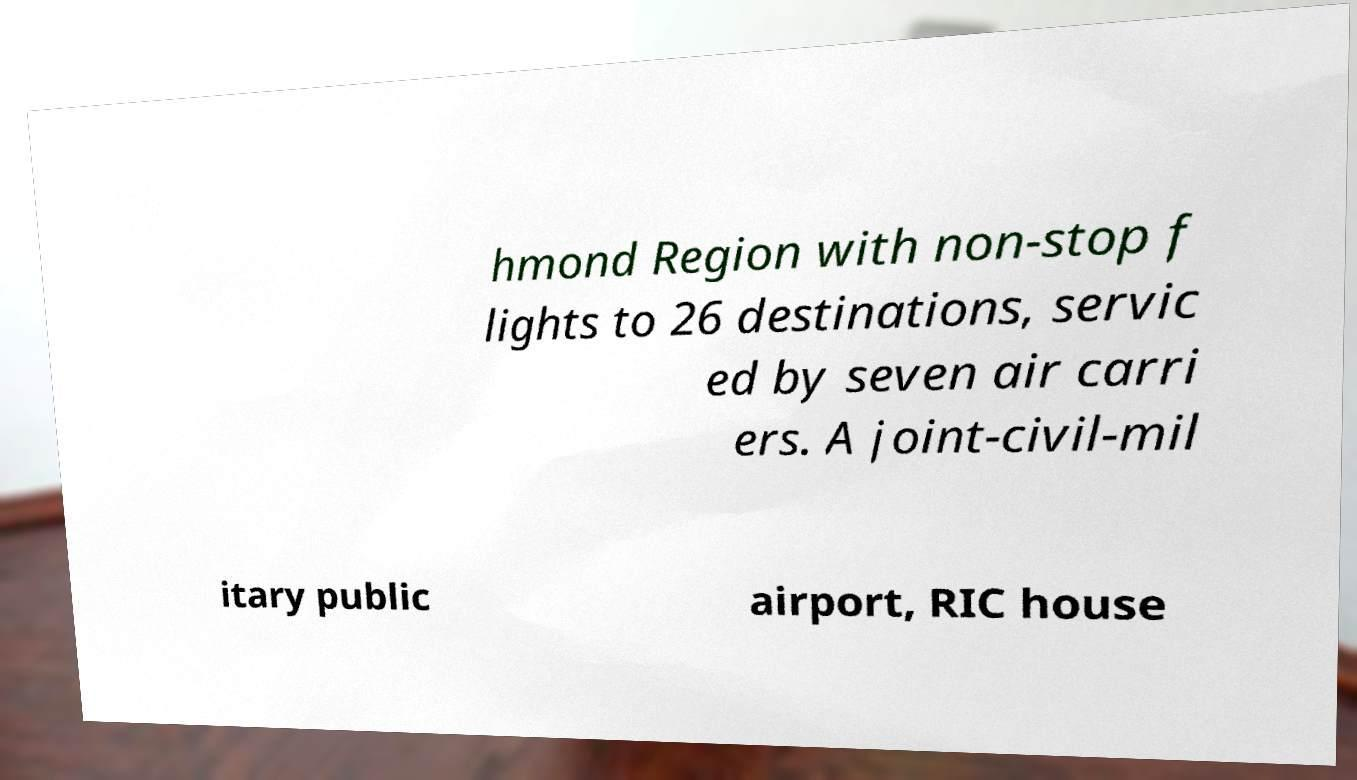Could you assist in decoding the text presented in this image and type it out clearly? hmond Region with non-stop f lights to 26 destinations, servic ed by seven air carri ers. A joint-civil-mil itary public airport, RIC house 